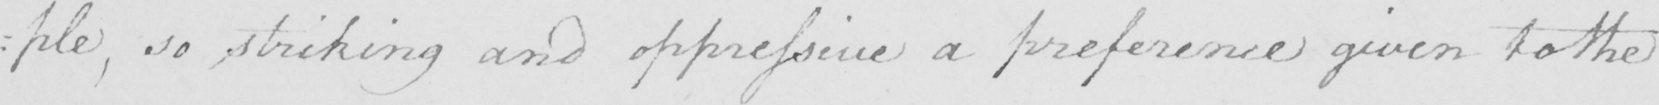What does this handwritten line say? : ple , so striking and oppressive a preference given to the 